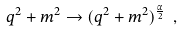<formula> <loc_0><loc_0><loc_500><loc_500>q ^ { 2 } + m ^ { 2 } \to ( q ^ { 2 } + m ^ { 2 } ) ^ { \frac { \alpha } { 2 } } \ ,</formula> 